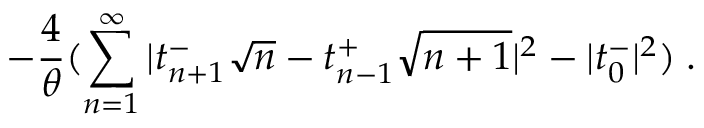Convert formula to latex. <formula><loc_0><loc_0><loc_500><loc_500>- \frac { 4 } { \theta } ( \sum _ { n = 1 } ^ { \infty } | t _ { n + 1 } ^ { - } \sqrt { n } - t _ { n - 1 } ^ { + } \sqrt { n + 1 } | ^ { 2 } - | t _ { 0 } ^ { - } | ^ { 2 } ) \, .</formula> 